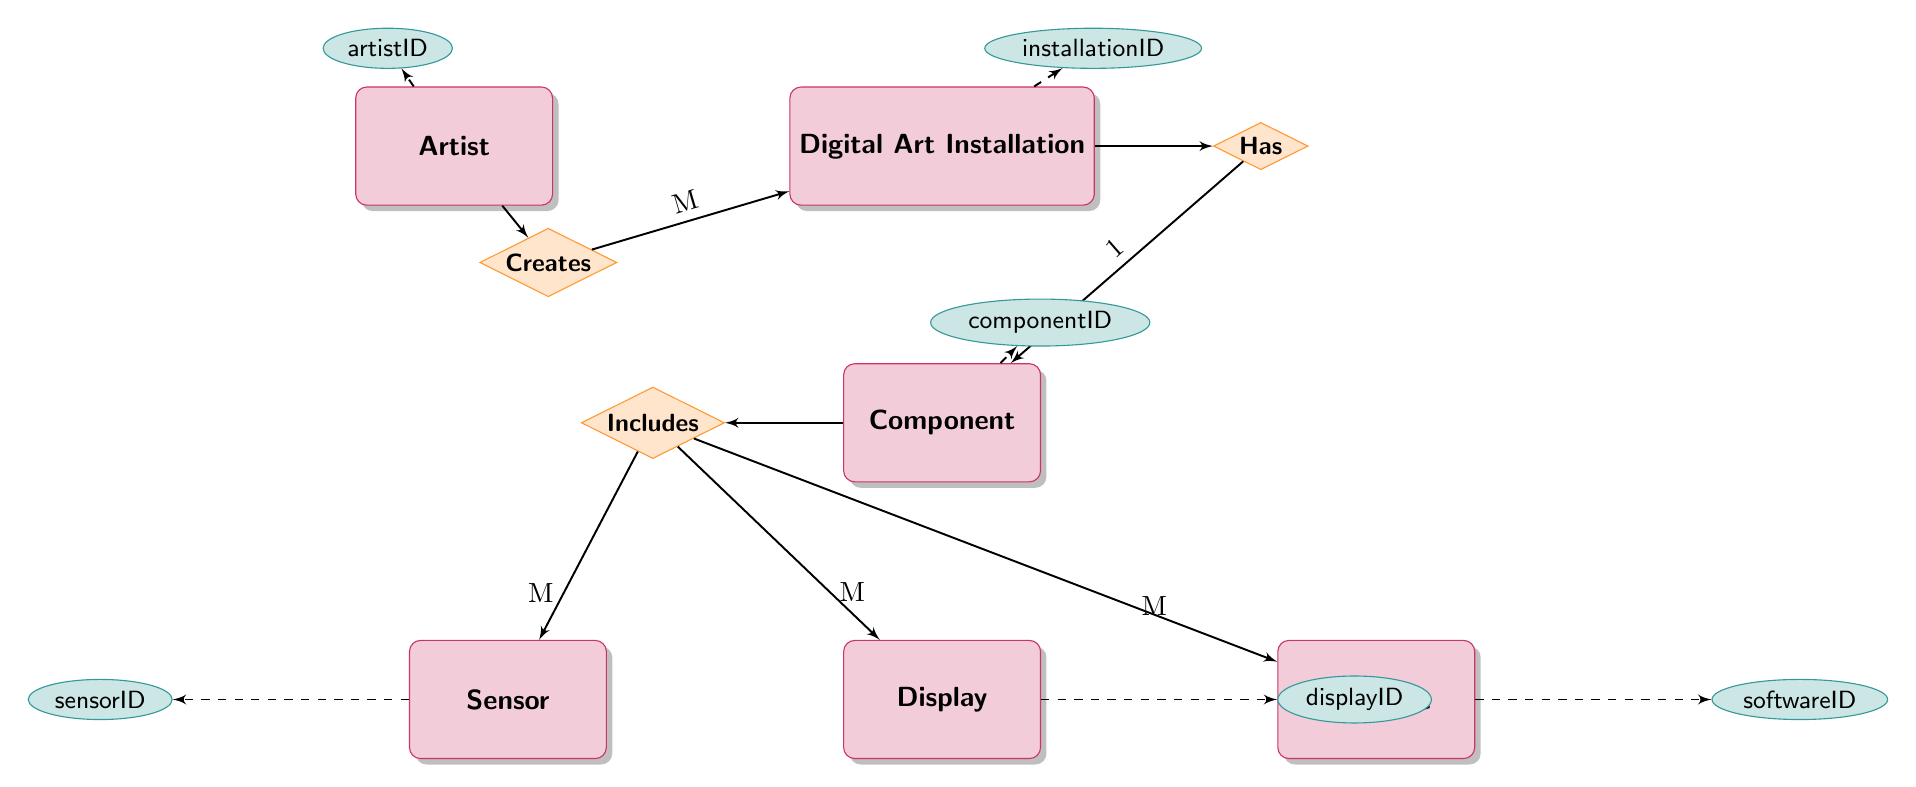What is the relationship between Digital Art Installation and Artist? The diagram shows that there is a "Creates" relationship between the Digital Art Installation and Artist entities. This indicates that one or more artists can create multiple digital art installations.
Answer: Creates How many components can be included in a Digital Art Installation? The diagram indicates that the relationship between Digital Art Installation and Component is "One-to-Many", meaning that each Digital Art Installation can include multiple components, but each component belongs to only one installation.
Answer: Many What is the type of component that can have sensors? The diagram specifies that there is a "One-to-Many" relationship between Component and Sensor, which means that a component can include multiple sensors. The type of the component is identified as "Component".
Answer: Component Which entity has an attribute called installationID? The attribute installationID is directly linked to the Digital Art Installation entity in the diagram, showing that it belongs to that entity.
Answer: Digital Art Installation How many display types can be associated with a single component? The diagram shows that there is a "One-to-Many" relationship between Component and Display, which indicates that a single component can have multiple types of displays associated with it.
Answer: Many How many attributes does the Sensor entity have? The Sensor entity is shown with four attributes: sensorID, type, location, and specifications, which can be counted directly from the diagram.
Answer: Four What type of relationship exists between Component and Software? The diagram indicates a "One-to-Many" relationship between the Component and Software entities. This means that a single component can have multiple software applications controlling or interfacing with it.
Answer: One-to-Many What is the minimum number of artists required to create a Digital Art Installation? The diagram indicates a "Many-to-One" relationship between Digital Art Installation and Artist, meaning one or more artists can contribute to a single installation, but each installation is created by at least one artist. Therefore, the minimum number is one.
Answer: One What is the only attribute displayed for the Display entity? The diagram shows that the Display entity has one listed attribute: displayID. This is the only attribute shown for this entity.
Answer: displayID 